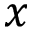<formula> <loc_0><loc_0><loc_500><loc_500>x</formula> 